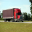Given the setting of the image, how does the design of the semi-truck enhance its functionality on highways? The semi-truck's design, noticeable in the image, features aerodynamic components such as a streamlined cabin and a contoured trailer, which help reduce air resistance during travel. This is particularly beneficial for highway use, where higher speeds necessitate better aerodynamics. The tires appear thick and durable, suitable for maintaining stability and grip at high speeds. The broad side mirrors and elevated cabin provide the driver with enhanced visibility, essential for safe navigation and maneuvering on busy highways. 